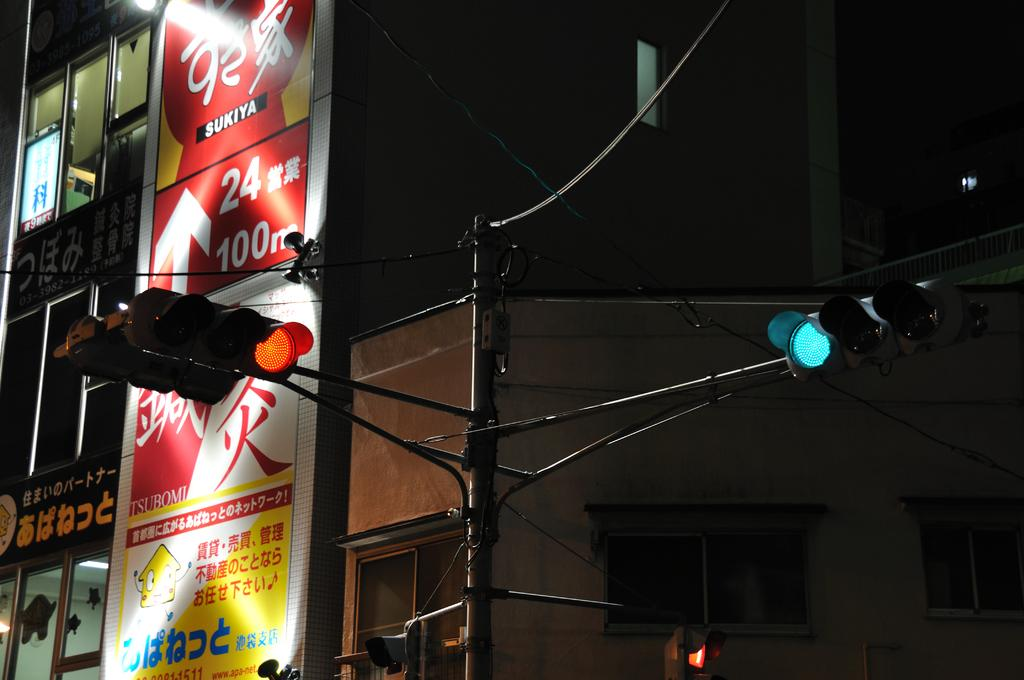Provide a one-sentence caption for the provided image. an intersection with a red sukiya billboard in the background. 